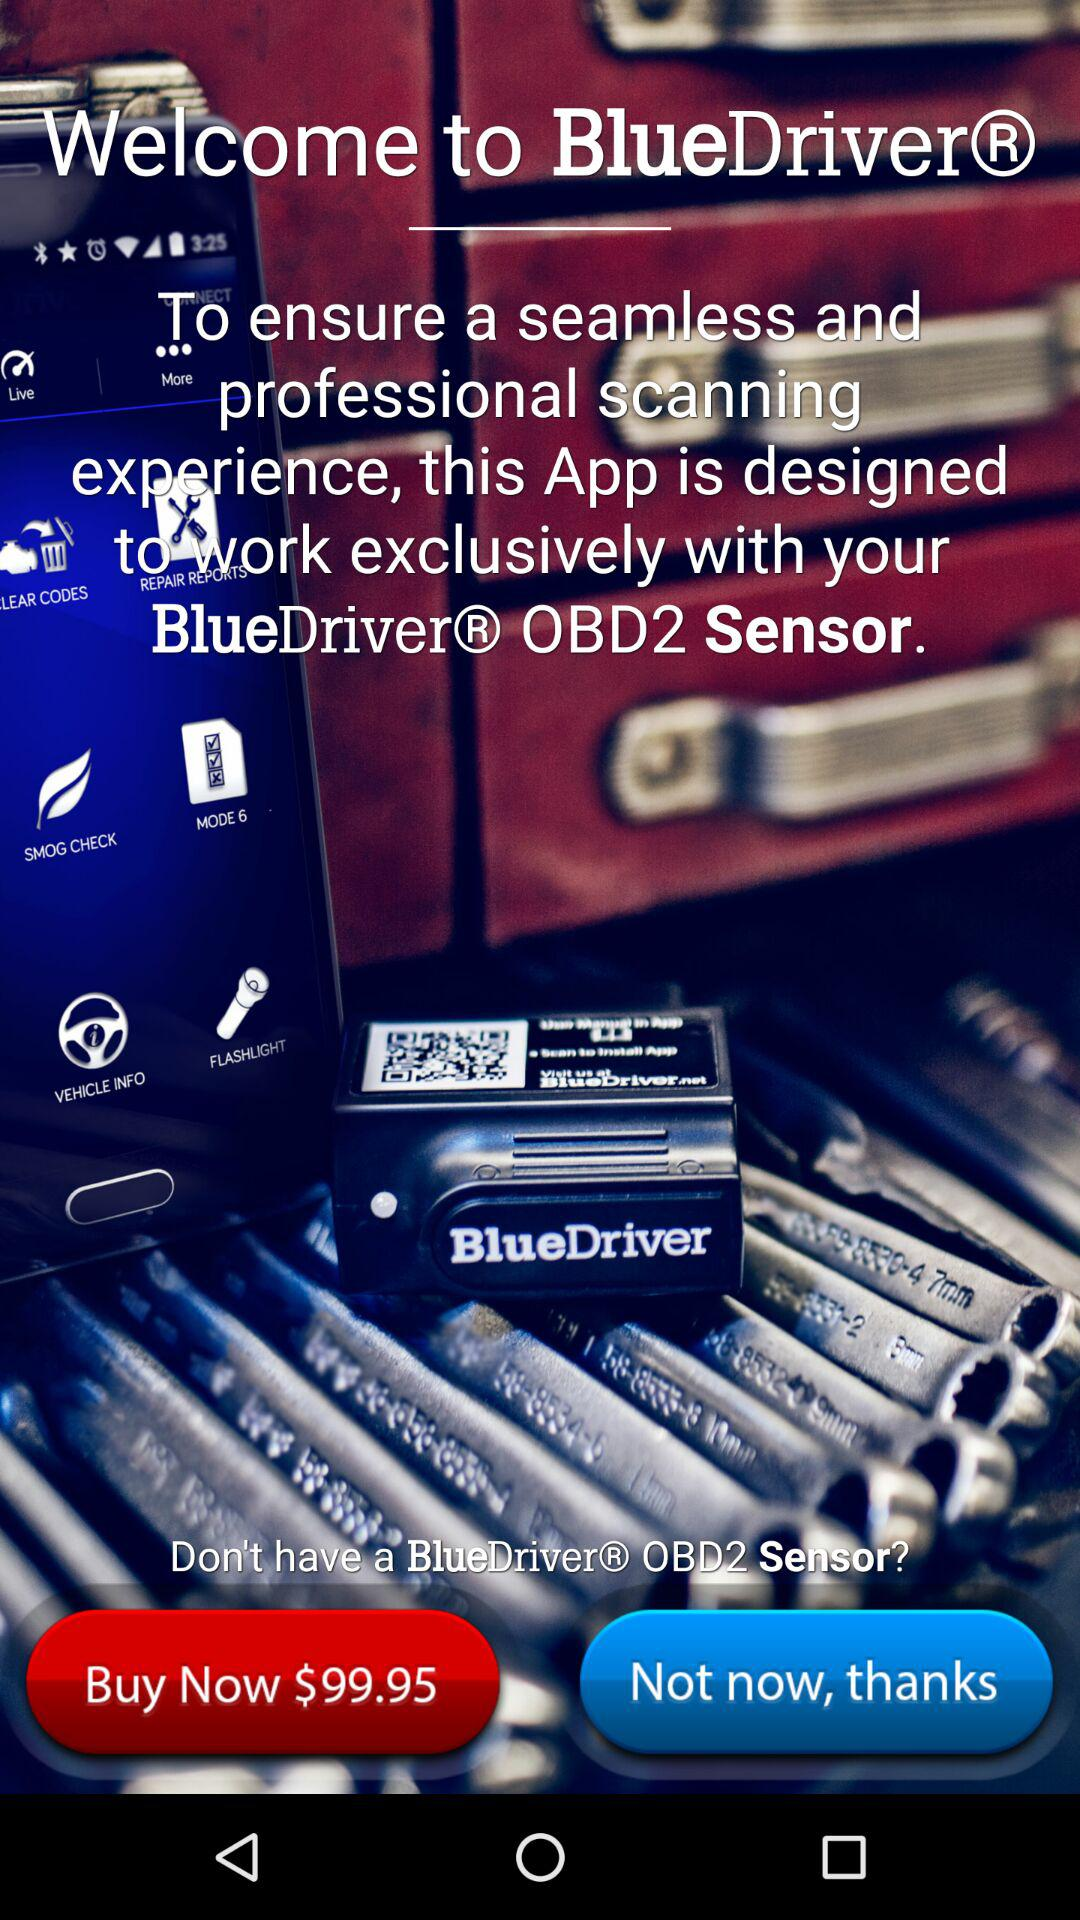What is the price of the "BlueDriver® OBD2 Sensor"? The price of the "BlueDriver® OBD2 Sensor" is $99.95. 